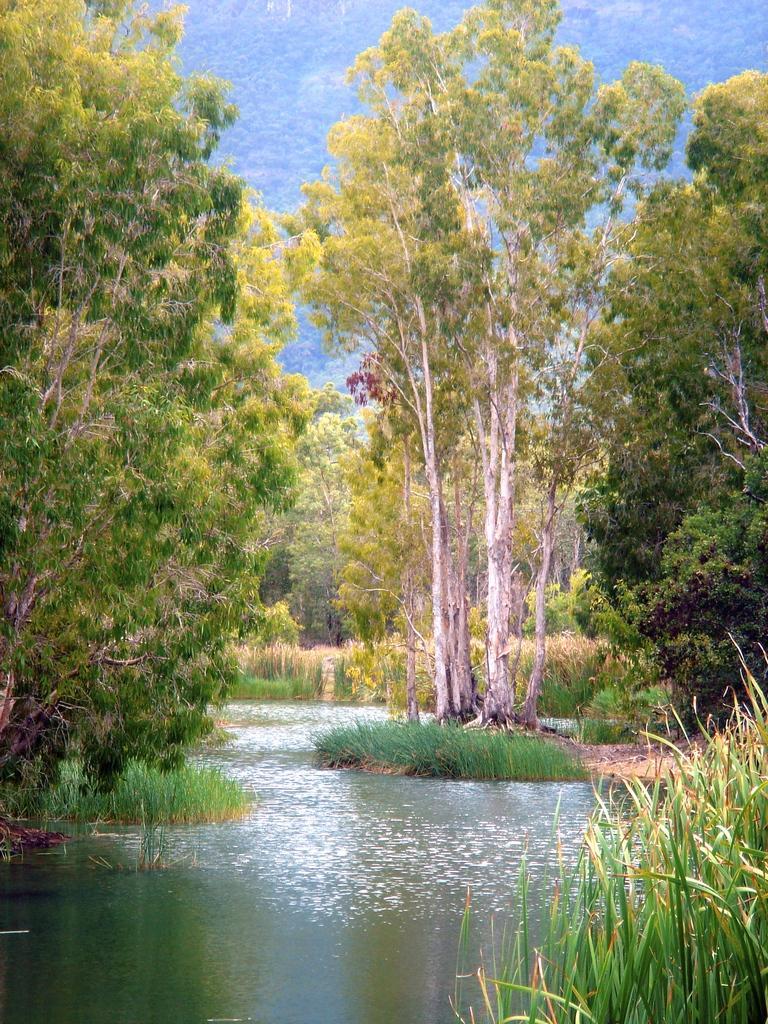Could you give a brief overview of what you see in this image? In this image, we can see trees, plants and hills. At the bottom, there is water. 